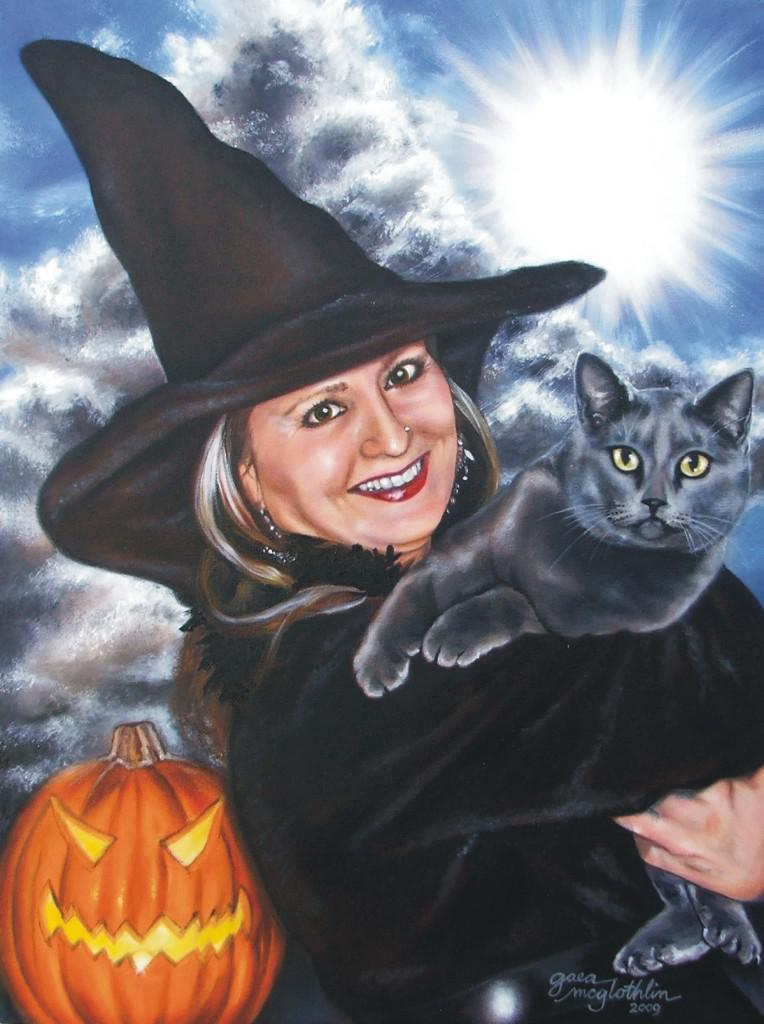What is the main subject of the image? There is a painting in the image. How many tomatoes are depicted in the painting? There is no information about tomatoes or any other specific elements in the painting, as only the fact that there is a painting in the image is provided. 